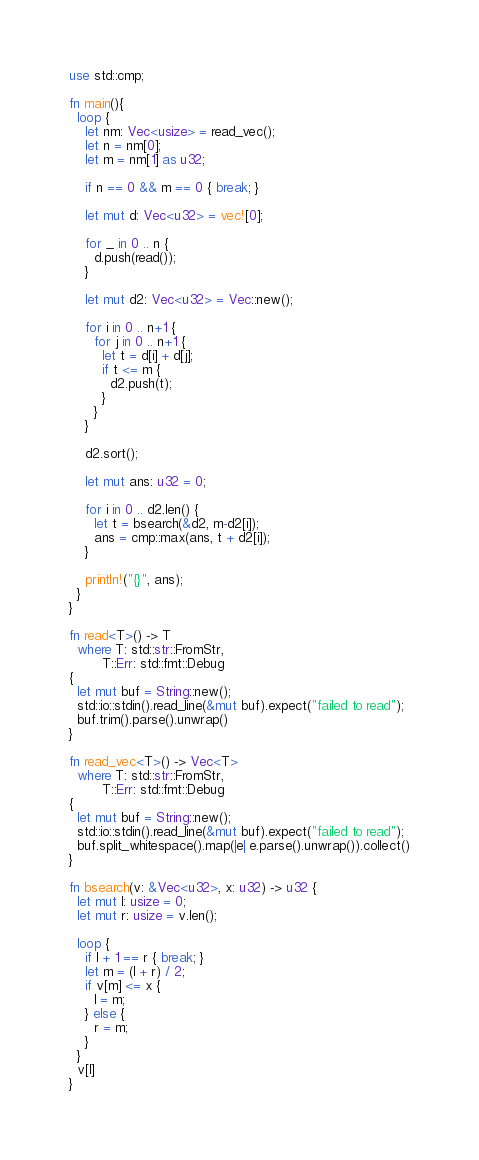Convert code to text. <code><loc_0><loc_0><loc_500><loc_500><_Rust_>use std::cmp;

fn main(){
  loop {
    let nm: Vec<usize> = read_vec();
    let n = nm[0];
    let m = nm[1] as u32;

    if n == 0 && m == 0 { break; }
    
    let mut d: Vec<u32> = vec![0];
  
    for _ in 0 .. n {
      d.push(read());
    }

    let mut d2: Vec<u32> = Vec::new();
    
    for i in 0 .. n+1 {
      for j in 0 .. n+1 {
        let t = d[i] + d[j];
        if t <= m {
          d2.push(t);
        }
      }
    }

    d2.sort();

    let mut ans: u32 = 0;
    
    for i in 0 .. d2.len() {
      let t = bsearch(&d2, m-d2[i]);
      ans = cmp::max(ans, t + d2[i]);
    }
    
    println!("{}", ans);
  }
}

fn read<T>() -> T
  where T: std::str::FromStr,
        T::Err: std::fmt::Debug
{
  let mut buf = String::new();
  std::io::stdin().read_line(&mut buf).expect("failed to read");
  buf.trim().parse().unwrap()
}

fn read_vec<T>() -> Vec<T>
  where T: std::str::FromStr,
        T::Err: std::fmt::Debug
{
  let mut buf = String::new();
  std::io::stdin().read_line(&mut buf).expect("failed to read");
  buf.split_whitespace().map(|e| e.parse().unwrap()).collect()
}

fn bsearch(v: &Vec<u32>, x: u32) -> u32 {
  let mut l: usize = 0;
  let mut r: usize = v.len();
  
  loop {
    if l + 1 == r { break; }
    let m = (l + r) / 2;
    if v[m] <= x {
      l = m;
    } else {
      r = m;
    }
  }
  v[l]
}

</code> 